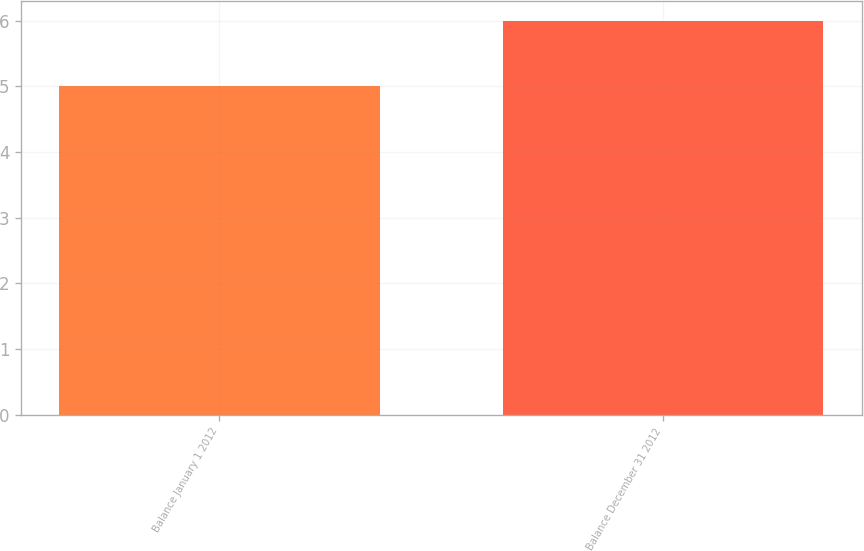Convert chart. <chart><loc_0><loc_0><loc_500><loc_500><bar_chart><fcel>Balance January 1 2012<fcel>Balance December 31 2012<nl><fcel>5<fcel>6<nl></chart> 